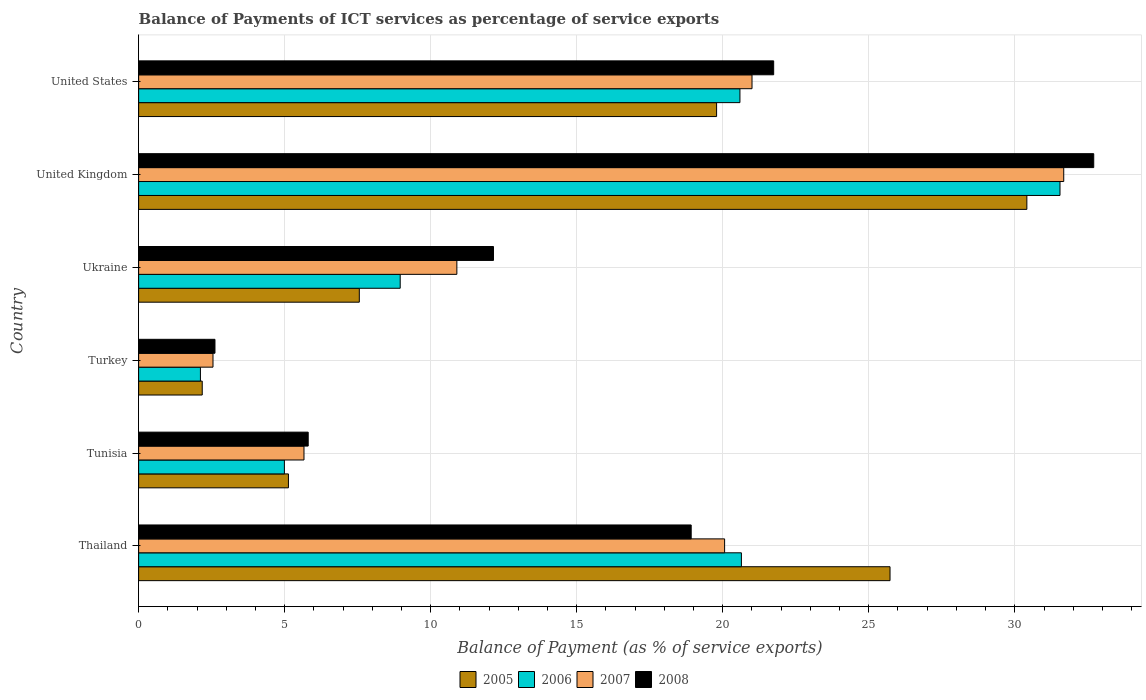How many different coloured bars are there?
Your answer should be compact. 4. How many groups of bars are there?
Your response must be concise. 6. Are the number of bars per tick equal to the number of legend labels?
Your answer should be very brief. Yes. Are the number of bars on each tick of the Y-axis equal?
Give a very brief answer. Yes. How many bars are there on the 1st tick from the top?
Your response must be concise. 4. What is the label of the 6th group of bars from the top?
Provide a short and direct response. Thailand. What is the balance of payments of ICT services in 2005 in Tunisia?
Provide a short and direct response. 5.13. Across all countries, what is the maximum balance of payments of ICT services in 2007?
Provide a succinct answer. 31.68. Across all countries, what is the minimum balance of payments of ICT services in 2008?
Give a very brief answer. 2.61. What is the total balance of payments of ICT services in 2007 in the graph?
Give a very brief answer. 91.85. What is the difference between the balance of payments of ICT services in 2005 in Tunisia and that in United Kingdom?
Your answer should be very brief. -25.28. What is the difference between the balance of payments of ICT services in 2006 in Ukraine and the balance of payments of ICT services in 2008 in United Kingdom?
Offer a terse response. -23.75. What is the average balance of payments of ICT services in 2007 per country?
Offer a very short reply. 15.31. What is the difference between the balance of payments of ICT services in 2007 and balance of payments of ICT services in 2005 in Thailand?
Your response must be concise. -5.66. What is the ratio of the balance of payments of ICT services in 2006 in Tunisia to that in United Kingdom?
Your answer should be very brief. 0.16. Is the balance of payments of ICT services in 2006 in Thailand less than that in Ukraine?
Make the answer very short. No. What is the difference between the highest and the second highest balance of payments of ICT services in 2005?
Your answer should be compact. 4.68. What is the difference between the highest and the lowest balance of payments of ICT services in 2007?
Your answer should be very brief. 29.13. In how many countries, is the balance of payments of ICT services in 2008 greater than the average balance of payments of ICT services in 2008 taken over all countries?
Your answer should be very brief. 3. Is the sum of the balance of payments of ICT services in 2008 in Thailand and Tunisia greater than the maximum balance of payments of ICT services in 2005 across all countries?
Keep it short and to the point. No. Are all the bars in the graph horizontal?
Offer a terse response. Yes. Does the graph contain any zero values?
Provide a succinct answer. No. Does the graph contain grids?
Provide a short and direct response. Yes. Where does the legend appear in the graph?
Keep it short and to the point. Bottom center. How are the legend labels stacked?
Offer a terse response. Horizontal. What is the title of the graph?
Provide a succinct answer. Balance of Payments of ICT services as percentage of service exports. What is the label or title of the X-axis?
Give a very brief answer. Balance of Payment (as % of service exports). What is the label or title of the Y-axis?
Offer a very short reply. Country. What is the Balance of Payment (as % of service exports) of 2005 in Thailand?
Give a very brief answer. 25.73. What is the Balance of Payment (as % of service exports) of 2006 in Thailand?
Provide a short and direct response. 20.64. What is the Balance of Payment (as % of service exports) in 2007 in Thailand?
Your answer should be very brief. 20.06. What is the Balance of Payment (as % of service exports) in 2008 in Thailand?
Give a very brief answer. 18.92. What is the Balance of Payment (as % of service exports) of 2005 in Tunisia?
Ensure brevity in your answer.  5.13. What is the Balance of Payment (as % of service exports) in 2006 in Tunisia?
Your answer should be very brief. 4.99. What is the Balance of Payment (as % of service exports) in 2007 in Tunisia?
Your answer should be compact. 5.66. What is the Balance of Payment (as % of service exports) in 2008 in Tunisia?
Your answer should be compact. 5.81. What is the Balance of Payment (as % of service exports) of 2005 in Turkey?
Your answer should be very brief. 2.18. What is the Balance of Payment (as % of service exports) of 2006 in Turkey?
Your answer should be very brief. 2.12. What is the Balance of Payment (as % of service exports) in 2007 in Turkey?
Your answer should be very brief. 2.55. What is the Balance of Payment (as % of service exports) of 2008 in Turkey?
Give a very brief answer. 2.61. What is the Balance of Payment (as % of service exports) in 2005 in Ukraine?
Provide a succinct answer. 7.56. What is the Balance of Payment (as % of service exports) in 2006 in Ukraine?
Keep it short and to the point. 8.96. What is the Balance of Payment (as % of service exports) in 2007 in Ukraine?
Provide a succinct answer. 10.9. What is the Balance of Payment (as % of service exports) of 2008 in Ukraine?
Offer a very short reply. 12.15. What is the Balance of Payment (as % of service exports) in 2005 in United Kingdom?
Your answer should be compact. 30.41. What is the Balance of Payment (as % of service exports) of 2006 in United Kingdom?
Your answer should be very brief. 31.55. What is the Balance of Payment (as % of service exports) in 2007 in United Kingdom?
Provide a succinct answer. 31.68. What is the Balance of Payment (as % of service exports) of 2008 in United Kingdom?
Offer a very short reply. 32.7. What is the Balance of Payment (as % of service exports) of 2005 in United States?
Make the answer very short. 19.79. What is the Balance of Payment (as % of service exports) in 2006 in United States?
Provide a short and direct response. 20.59. What is the Balance of Payment (as % of service exports) in 2007 in United States?
Offer a terse response. 21. What is the Balance of Payment (as % of service exports) in 2008 in United States?
Your answer should be compact. 21.74. Across all countries, what is the maximum Balance of Payment (as % of service exports) in 2005?
Make the answer very short. 30.41. Across all countries, what is the maximum Balance of Payment (as % of service exports) of 2006?
Provide a succinct answer. 31.55. Across all countries, what is the maximum Balance of Payment (as % of service exports) in 2007?
Ensure brevity in your answer.  31.68. Across all countries, what is the maximum Balance of Payment (as % of service exports) in 2008?
Give a very brief answer. 32.7. Across all countries, what is the minimum Balance of Payment (as % of service exports) in 2005?
Provide a short and direct response. 2.18. Across all countries, what is the minimum Balance of Payment (as % of service exports) of 2006?
Your response must be concise. 2.12. Across all countries, what is the minimum Balance of Payment (as % of service exports) in 2007?
Give a very brief answer. 2.55. Across all countries, what is the minimum Balance of Payment (as % of service exports) in 2008?
Offer a terse response. 2.61. What is the total Balance of Payment (as % of service exports) of 2005 in the graph?
Ensure brevity in your answer.  90.79. What is the total Balance of Payment (as % of service exports) in 2006 in the graph?
Offer a very short reply. 88.84. What is the total Balance of Payment (as % of service exports) of 2007 in the graph?
Give a very brief answer. 91.85. What is the total Balance of Payment (as % of service exports) of 2008 in the graph?
Provide a succinct answer. 93.94. What is the difference between the Balance of Payment (as % of service exports) of 2005 in Thailand and that in Tunisia?
Make the answer very short. 20.6. What is the difference between the Balance of Payment (as % of service exports) in 2006 in Thailand and that in Tunisia?
Offer a very short reply. 15.65. What is the difference between the Balance of Payment (as % of service exports) in 2007 in Thailand and that in Tunisia?
Give a very brief answer. 14.4. What is the difference between the Balance of Payment (as % of service exports) in 2008 in Thailand and that in Tunisia?
Ensure brevity in your answer.  13.11. What is the difference between the Balance of Payment (as % of service exports) in 2005 in Thailand and that in Turkey?
Keep it short and to the point. 23.55. What is the difference between the Balance of Payment (as % of service exports) of 2006 in Thailand and that in Turkey?
Your response must be concise. 18.52. What is the difference between the Balance of Payment (as % of service exports) of 2007 in Thailand and that in Turkey?
Give a very brief answer. 17.52. What is the difference between the Balance of Payment (as % of service exports) of 2008 in Thailand and that in Turkey?
Your answer should be compact. 16.31. What is the difference between the Balance of Payment (as % of service exports) of 2005 in Thailand and that in Ukraine?
Offer a terse response. 18.17. What is the difference between the Balance of Payment (as % of service exports) in 2006 in Thailand and that in Ukraine?
Your response must be concise. 11.68. What is the difference between the Balance of Payment (as % of service exports) of 2007 in Thailand and that in Ukraine?
Provide a short and direct response. 9.17. What is the difference between the Balance of Payment (as % of service exports) in 2008 in Thailand and that in Ukraine?
Ensure brevity in your answer.  6.77. What is the difference between the Balance of Payment (as % of service exports) of 2005 in Thailand and that in United Kingdom?
Ensure brevity in your answer.  -4.68. What is the difference between the Balance of Payment (as % of service exports) of 2006 in Thailand and that in United Kingdom?
Provide a succinct answer. -10.91. What is the difference between the Balance of Payment (as % of service exports) in 2007 in Thailand and that in United Kingdom?
Provide a succinct answer. -11.61. What is the difference between the Balance of Payment (as % of service exports) in 2008 in Thailand and that in United Kingdom?
Offer a very short reply. -13.78. What is the difference between the Balance of Payment (as % of service exports) of 2005 in Thailand and that in United States?
Give a very brief answer. 5.94. What is the difference between the Balance of Payment (as % of service exports) in 2006 in Thailand and that in United States?
Your answer should be compact. 0.05. What is the difference between the Balance of Payment (as % of service exports) in 2007 in Thailand and that in United States?
Your answer should be compact. -0.94. What is the difference between the Balance of Payment (as % of service exports) in 2008 in Thailand and that in United States?
Make the answer very short. -2.82. What is the difference between the Balance of Payment (as % of service exports) in 2005 in Tunisia and that in Turkey?
Make the answer very short. 2.95. What is the difference between the Balance of Payment (as % of service exports) in 2006 in Tunisia and that in Turkey?
Your response must be concise. 2.88. What is the difference between the Balance of Payment (as % of service exports) in 2007 in Tunisia and that in Turkey?
Make the answer very short. 3.12. What is the difference between the Balance of Payment (as % of service exports) in 2008 in Tunisia and that in Turkey?
Make the answer very short. 3.19. What is the difference between the Balance of Payment (as % of service exports) in 2005 in Tunisia and that in Ukraine?
Offer a very short reply. -2.43. What is the difference between the Balance of Payment (as % of service exports) of 2006 in Tunisia and that in Ukraine?
Provide a short and direct response. -3.97. What is the difference between the Balance of Payment (as % of service exports) of 2007 in Tunisia and that in Ukraine?
Ensure brevity in your answer.  -5.23. What is the difference between the Balance of Payment (as % of service exports) in 2008 in Tunisia and that in Ukraine?
Your response must be concise. -6.34. What is the difference between the Balance of Payment (as % of service exports) in 2005 in Tunisia and that in United Kingdom?
Your answer should be very brief. -25.28. What is the difference between the Balance of Payment (as % of service exports) of 2006 in Tunisia and that in United Kingdom?
Keep it short and to the point. -26.56. What is the difference between the Balance of Payment (as % of service exports) in 2007 in Tunisia and that in United Kingdom?
Give a very brief answer. -26.01. What is the difference between the Balance of Payment (as % of service exports) in 2008 in Tunisia and that in United Kingdom?
Provide a short and direct response. -26.9. What is the difference between the Balance of Payment (as % of service exports) in 2005 in Tunisia and that in United States?
Give a very brief answer. -14.66. What is the difference between the Balance of Payment (as % of service exports) of 2006 in Tunisia and that in United States?
Your response must be concise. -15.6. What is the difference between the Balance of Payment (as % of service exports) of 2007 in Tunisia and that in United States?
Provide a succinct answer. -15.34. What is the difference between the Balance of Payment (as % of service exports) of 2008 in Tunisia and that in United States?
Your answer should be compact. -15.94. What is the difference between the Balance of Payment (as % of service exports) of 2005 in Turkey and that in Ukraine?
Keep it short and to the point. -5.38. What is the difference between the Balance of Payment (as % of service exports) in 2006 in Turkey and that in Ukraine?
Offer a very short reply. -6.84. What is the difference between the Balance of Payment (as % of service exports) of 2007 in Turkey and that in Ukraine?
Give a very brief answer. -8.35. What is the difference between the Balance of Payment (as % of service exports) of 2008 in Turkey and that in Ukraine?
Provide a succinct answer. -9.54. What is the difference between the Balance of Payment (as % of service exports) in 2005 in Turkey and that in United Kingdom?
Keep it short and to the point. -28.23. What is the difference between the Balance of Payment (as % of service exports) of 2006 in Turkey and that in United Kingdom?
Provide a succinct answer. -29.43. What is the difference between the Balance of Payment (as % of service exports) in 2007 in Turkey and that in United Kingdom?
Your response must be concise. -29.13. What is the difference between the Balance of Payment (as % of service exports) of 2008 in Turkey and that in United Kingdom?
Ensure brevity in your answer.  -30.09. What is the difference between the Balance of Payment (as % of service exports) of 2005 in Turkey and that in United States?
Your answer should be very brief. -17.61. What is the difference between the Balance of Payment (as % of service exports) in 2006 in Turkey and that in United States?
Offer a very short reply. -18.47. What is the difference between the Balance of Payment (as % of service exports) of 2007 in Turkey and that in United States?
Provide a short and direct response. -18.46. What is the difference between the Balance of Payment (as % of service exports) in 2008 in Turkey and that in United States?
Offer a terse response. -19.13. What is the difference between the Balance of Payment (as % of service exports) in 2005 in Ukraine and that in United Kingdom?
Ensure brevity in your answer.  -22.86. What is the difference between the Balance of Payment (as % of service exports) in 2006 in Ukraine and that in United Kingdom?
Your answer should be compact. -22.59. What is the difference between the Balance of Payment (as % of service exports) of 2007 in Ukraine and that in United Kingdom?
Provide a short and direct response. -20.78. What is the difference between the Balance of Payment (as % of service exports) of 2008 in Ukraine and that in United Kingdom?
Give a very brief answer. -20.55. What is the difference between the Balance of Payment (as % of service exports) of 2005 in Ukraine and that in United States?
Ensure brevity in your answer.  -12.23. What is the difference between the Balance of Payment (as % of service exports) in 2006 in Ukraine and that in United States?
Keep it short and to the point. -11.63. What is the difference between the Balance of Payment (as % of service exports) of 2007 in Ukraine and that in United States?
Your answer should be compact. -10.11. What is the difference between the Balance of Payment (as % of service exports) in 2008 in Ukraine and that in United States?
Provide a succinct answer. -9.59. What is the difference between the Balance of Payment (as % of service exports) in 2005 in United Kingdom and that in United States?
Keep it short and to the point. 10.62. What is the difference between the Balance of Payment (as % of service exports) in 2006 in United Kingdom and that in United States?
Your answer should be very brief. 10.96. What is the difference between the Balance of Payment (as % of service exports) of 2007 in United Kingdom and that in United States?
Keep it short and to the point. 10.67. What is the difference between the Balance of Payment (as % of service exports) in 2008 in United Kingdom and that in United States?
Provide a short and direct response. 10.96. What is the difference between the Balance of Payment (as % of service exports) in 2005 in Thailand and the Balance of Payment (as % of service exports) in 2006 in Tunisia?
Keep it short and to the point. 20.74. What is the difference between the Balance of Payment (as % of service exports) of 2005 in Thailand and the Balance of Payment (as % of service exports) of 2007 in Tunisia?
Give a very brief answer. 20.07. What is the difference between the Balance of Payment (as % of service exports) in 2005 in Thailand and the Balance of Payment (as % of service exports) in 2008 in Tunisia?
Keep it short and to the point. 19.92. What is the difference between the Balance of Payment (as % of service exports) in 2006 in Thailand and the Balance of Payment (as % of service exports) in 2007 in Tunisia?
Keep it short and to the point. 14.98. What is the difference between the Balance of Payment (as % of service exports) in 2006 in Thailand and the Balance of Payment (as % of service exports) in 2008 in Tunisia?
Your response must be concise. 14.83. What is the difference between the Balance of Payment (as % of service exports) of 2007 in Thailand and the Balance of Payment (as % of service exports) of 2008 in Tunisia?
Offer a very short reply. 14.26. What is the difference between the Balance of Payment (as % of service exports) of 2005 in Thailand and the Balance of Payment (as % of service exports) of 2006 in Turkey?
Give a very brief answer. 23.61. What is the difference between the Balance of Payment (as % of service exports) in 2005 in Thailand and the Balance of Payment (as % of service exports) in 2007 in Turkey?
Your answer should be very brief. 23.18. What is the difference between the Balance of Payment (as % of service exports) in 2005 in Thailand and the Balance of Payment (as % of service exports) in 2008 in Turkey?
Your response must be concise. 23.11. What is the difference between the Balance of Payment (as % of service exports) in 2006 in Thailand and the Balance of Payment (as % of service exports) in 2007 in Turkey?
Your response must be concise. 18.09. What is the difference between the Balance of Payment (as % of service exports) in 2006 in Thailand and the Balance of Payment (as % of service exports) in 2008 in Turkey?
Ensure brevity in your answer.  18.03. What is the difference between the Balance of Payment (as % of service exports) of 2007 in Thailand and the Balance of Payment (as % of service exports) of 2008 in Turkey?
Provide a short and direct response. 17.45. What is the difference between the Balance of Payment (as % of service exports) in 2005 in Thailand and the Balance of Payment (as % of service exports) in 2006 in Ukraine?
Your answer should be compact. 16.77. What is the difference between the Balance of Payment (as % of service exports) in 2005 in Thailand and the Balance of Payment (as % of service exports) in 2007 in Ukraine?
Keep it short and to the point. 14.83. What is the difference between the Balance of Payment (as % of service exports) in 2005 in Thailand and the Balance of Payment (as % of service exports) in 2008 in Ukraine?
Give a very brief answer. 13.58. What is the difference between the Balance of Payment (as % of service exports) of 2006 in Thailand and the Balance of Payment (as % of service exports) of 2007 in Ukraine?
Provide a short and direct response. 9.74. What is the difference between the Balance of Payment (as % of service exports) in 2006 in Thailand and the Balance of Payment (as % of service exports) in 2008 in Ukraine?
Offer a very short reply. 8.49. What is the difference between the Balance of Payment (as % of service exports) in 2007 in Thailand and the Balance of Payment (as % of service exports) in 2008 in Ukraine?
Provide a short and direct response. 7.91. What is the difference between the Balance of Payment (as % of service exports) of 2005 in Thailand and the Balance of Payment (as % of service exports) of 2006 in United Kingdom?
Make the answer very short. -5.82. What is the difference between the Balance of Payment (as % of service exports) in 2005 in Thailand and the Balance of Payment (as % of service exports) in 2007 in United Kingdom?
Your response must be concise. -5.95. What is the difference between the Balance of Payment (as % of service exports) of 2005 in Thailand and the Balance of Payment (as % of service exports) of 2008 in United Kingdom?
Give a very brief answer. -6.97. What is the difference between the Balance of Payment (as % of service exports) of 2006 in Thailand and the Balance of Payment (as % of service exports) of 2007 in United Kingdom?
Offer a terse response. -11.04. What is the difference between the Balance of Payment (as % of service exports) in 2006 in Thailand and the Balance of Payment (as % of service exports) in 2008 in United Kingdom?
Ensure brevity in your answer.  -12.06. What is the difference between the Balance of Payment (as % of service exports) of 2007 in Thailand and the Balance of Payment (as % of service exports) of 2008 in United Kingdom?
Ensure brevity in your answer.  -12.64. What is the difference between the Balance of Payment (as % of service exports) of 2005 in Thailand and the Balance of Payment (as % of service exports) of 2006 in United States?
Make the answer very short. 5.14. What is the difference between the Balance of Payment (as % of service exports) in 2005 in Thailand and the Balance of Payment (as % of service exports) in 2007 in United States?
Offer a very short reply. 4.73. What is the difference between the Balance of Payment (as % of service exports) of 2005 in Thailand and the Balance of Payment (as % of service exports) of 2008 in United States?
Ensure brevity in your answer.  3.98. What is the difference between the Balance of Payment (as % of service exports) of 2006 in Thailand and the Balance of Payment (as % of service exports) of 2007 in United States?
Your answer should be compact. -0.36. What is the difference between the Balance of Payment (as % of service exports) of 2006 in Thailand and the Balance of Payment (as % of service exports) of 2008 in United States?
Give a very brief answer. -1.1. What is the difference between the Balance of Payment (as % of service exports) in 2007 in Thailand and the Balance of Payment (as % of service exports) in 2008 in United States?
Ensure brevity in your answer.  -1.68. What is the difference between the Balance of Payment (as % of service exports) of 2005 in Tunisia and the Balance of Payment (as % of service exports) of 2006 in Turkey?
Make the answer very short. 3.01. What is the difference between the Balance of Payment (as % of service exports) in 2005 in Tunisia and the Balance of Payment (as % of service exports) in 2007 in Turkey?
Provide a succinct answer. 2.58. What is the difference between the Balance of Payment (as % of service exports) in 2005 in Tunisia and the Balance of Payment (as % of service exports) in 2008 in Turkey?
Provide a short and direct response. 2.52. What is the difference between the Balance of Payment (as % of service exports) of 2006 in Tunisia and the Balance of Payment (as % of service exports) of 2007 in Turkey?
Offer a very short reply. 2.44. What is the difference between the Balance of Payment (as % of service exports) in 2006 in Tunisia and the Balance of Payment (as % of service exports) in 2008 in Turkey?
Offer a very short reply. 2.38. What is the difference between the Balance of Payment (as % of service exports) in 2007 in Tunisia and the Balance of Payment (as % of service exports) in 2008 in Turkey?
Keep it short and to the point. 3.05. What is the difference between the Balance of Payment (as % of service exports) in 2005 in Tunisia and the Balance of Payment (as % of service exports) in 2006 in Ukraine?
Your response must be concise. -3.83. What is the difference between the Balance of Payment (as % of service exports) in 2005 in Tunisia and the Balance of Payment (as % of service exports) in 2007 in Ukraine?
Your answer should be very brief. -5.77. What is the difference between the Balance of Payment (as % of service exports) in 2005 in Tunisia and the Balance of Payment (as % of service exports) in 2008 in Ukraine?
Give a very brief answer. -7.02. What is the difference between the Balance of Payment (as % of service exports) in 2006 in Tunisia and the Balance of Payment (as % of service exports) in 2007 in Ukraine?
Give a very brief answer. -5.91. What is the difference between the Balance of Payment (as % of service exports) in 2006 in Tunisia and the Balance of Payment (as % of service exports) in 2008 in Ukraine?
Your answer should be very brief. -7.16. What is the difference between the Balance of Payment (as % of service exports) of 2007 in Tunisia and the Balance of Payment (as % of service exports) of 2008 in Ukraine?
Your response must be concise. -6.49. What is the difference between the Balance of Payment (as % of service exports) of 2005 in Tunisia and the Balance of Payment (as % of service exports) of 2006 in United Kingdom?
Give a very brief answer. -26.42. What is the difference between the Balance of Payment (as % of service exports) of 2005 in Tunisia and the Balance of Payment (as % of service exports) of 2007 in United Kingdom?
Your answer should be compact. -26.55. What is the difference between the Balance of Payment (as % of service exports) in 2005 in Tunisia and the Balance of Payment (as % of service exports) in 2008 in United Kingdom?
Provide a short and direct response. -27.57. What is the difference between the Balance of Payment (as % of service exports) in 2006 in Tunisia and the Balance of Payment (as % of service exports) in 2007 in United Kingdom?
Ensure brevity in your answer.  -26.68. What is the difference between the Balance of Payment (as % of service exports) in 2006 in Tunisia and the Balance of Payment (as % of service exports) in 2008 in United Kingdom?
Ensure brevity in your answer.  -27.71. What is the difference between the Balance of Payment (as % of service exports) of 2007 in Tunisia and the Balance of Payment (as % of service exports) of 2008 in United Kingdom?
Your answer should be compact. -27.04. What is the difference between the Balance of Payment (as % of service exports) of 2005 in Tunisia and the Balance of Payment (as % of service exports) of 2006 in United States?
Your response must be concise. -15.46. What is the difference between the Balance of Payment (as % of service exports) in 2005 in Tunisia and the Balance of Payment (as % of service exports) in 2007 in United States?
Your answer should be very brief. -15.87. What is the difference between the Balance of Payment (as % of service exports) in 2005 in Tunisia and the Balance of Payment (as % of service exports) in 2008 in United States?
Provide a short and direct response. -16.61. What is the difference between the Balance of Payment (as % of service exports) in 2006 in Tunisia and the Balance of Payment (as % of service exports) in 2007 in United States?
Your answer should be compact. -16.01. What is the difference between the Balance of Payment (as % of service exports) in 2006 in Tunisia and the Balance of Payment (as % of service exports) in 2008 in United States?
Ensure brevity in your answer.  -16.75. What is the difference between the Balance of Payment (as % of service exports) of 2007 in Tunisia and the Balance of Payment (as % of service exports) of 2008 in United States?
Provide a succinct answer. -16.08. What is the difference between the Balance of Payment (as % of service exports) in 2005 in Turkey and the Balance of Payment (as % of service exports) in 2006 in Ukraine?
Your answer should be compact. -6.78. What is the difference between the Balance of Payment (as % of service exports) of 2005 in Turkey and the Balance of Payment (as % of service exports) of 2007 in Ukraine?
Offer a terse response. -8.72. What is the difference between the Balance of Payment (as % of service exports) in 2005 in Turkey and the Balance of Payment (as % of service exports) in 2008 in Ukraine?
Offer a very short reply. -9.97. What is the difference between the Balance of Payment (as % of service exports) of 2006 in Turkey and the Balance of Payment (as % of service exports) of 2007 in Ukraine?
Your answer should be very brief. -8.78. What is the difference between the Balance of Payment (as % of service exports) in 2006 in Turkey and the Balance of Payment (as % of service exports) in 2008 in Ukraine?
Ensure brevity in your answer.  -10.03. What is the difference between the Balance of Payment (as % of service exports) in 2007 in Turkey and the Balance of Payment (as % of service exports) in 2008 in Ukraine?
Give a very brief answer. -9.6. What is the difference between the Balance of Payment (as % of service exports) of 2005 in Turkey and the Balance of Payment (as % of service exports) of 2006 in United Kingdom?
Provide a short and direct response. -29.37. What is the difference between the Balance of Payment (as % of service exports) in 2005 in Turkey and the Balance of Payment (as % of service exports) in 2007 in United Kingdom?
Keep it short and to the point. -29.5. What is the difference between the Balance of Payment (as % of service exports) in 2005 in Turkey and the Balance of Payment (as % of service exports) in 2008 in United Kingdom?
Offer a terse response. -30.52. What is the difference between the Balance of Payment (as % of service exports) in 2006 in Turkey and the Balance of Payment (as % of service exports) in 2007 in United Kingdom?
Ensure brevity in your answer.  -29.56. What is the difference between the Balance of Payment (as % of service exports) of 2006 in Turkey and the Balance of Payment (as % of service exports) of 2008 in United Kingdom?
Your answer should be very brief. -30.59. What is the difference between the Balance of Payment (as % of service exports) in 2007 in Turkey and the Balance of Payment (as % of service exports) in 2008 in United Kingdom?
Provide a short and direct response. -30.16. What is the difference between the Balance of Payment (as % of service exports) of 2005 in Turkey and the Balance of Payment (as % of service exports) of 2006 in United States?
Provide a succinct answer. -18.41. What is the difference between the Balance of Payment (as % of service exports) of 2005 in Turkey and the Balance of Payment (as % of service exports) of 2007 in United States?
Keep it short and to the point. -18.82. What is the difference between the Balance of Payment (as % of service exports) of 2005 in Turkey and the Balance of Payment (as % of service exports) of 2008 in United States?
Your answer should be very brief. -19.57. What is the difference between the Balance of Payment (as % of service exports) of 2006 in Turkey and the Balance of Payment (as % of service exports) of 2007 in United States?
Keep it short and to the point. -18.89. What is the difference between the Balance of Payment (as % of service exports) in 2006 in Turkey and the Balance of Payment (as % of service exports) in 2008 in United States?
Your answer should be compact. -19.63. What is the difference between the Balance of Payment (as % of service exports) of 2007 in Turkey and the Balance of Payment (as % of service exports) of 2008 in United States?
Your response must be concise. -19.2. What is the difference between the Balance of Payment (as % of service exports) in 2005 in Ukraine and the Balance of Payment (as % of service exports) in 2006 in United Kingdom?
Keep it short and to the point. -23.99. What is the difference between the Balance of Payment (as % of service exports) in 2005 in Ukraine and the Balance of Payment (as % of service exports) in 2007 in United Kingdom?
Offer a very short reply. -24.12. What is the difference between the Balance of Payment (as % of service exports) in 2005 in Ukraine and the Balance of Payment (as % of service exports) in 2008 in United Kingdom?
Your response must be concise. -25.15. What is the difference between the Balance of Payment (as % of service exports) of 2006 in Ukraine and the Balance of Payment (as % of service exports) of 2007 in United Kingdom?
Ensure brevity in your answer.  -22.72. What is the difference between the Balance of Payment (as % of service exports) in 2006 in Ukraine and the Balance of Payment (as % of service exports) in 2008 in United Kingdom?
Make the answer very short. -23.75. What is the difference between the Balance of Payment (as % of service exports) in 2007 in Ukraine and the Balance of Payment (as % of service exports) in 2008 in United Kingdom?
Offer a terse response. -21.81. What is the difference between the Balance of Payment (as % of service exports) of 2005 in Ukraine and the Balance of Payment (as % of service exports) of 2006 in United States?
Your answer should be compact. -13.03. What is the difference between the Balance of Payment (as % of service exports) in 2005 in Ukraine and the Balance of Payment (as % of service exports) in 2007 in United States?
Ensure brevity in your answer.  -13.45. What is the difference between the Balance of Payment (as % of service exports) of 2005 in Ukraine and the Balance of Payment (as % of service exports) of 2008 in United States?
Your answer should be very brief. -14.19. What is the difference between the Balance of Payment (as % of service exports) of 2006 in Ukraine and the Balance of Payment (as % of service exports) of 2007 in United States?
Ensure brevity in your answer.  -12.05. What is the difference between the Balance of Payment (as % of service exports) of 2006 in Ukraine and the Balance of Payment (as % of service exports) of 2008 in United States?
Keep it short and to the point. -12.79. What is the difference between the Balance of Payment (as % of service exports) in 2007 in Ukraine and the Balance of Payment (as % of service exports) in 2008 in United States?
Offer a terse response. -10.85. What is the difference between the Balance of Payment (as % of service exports) in 2005 in United Kingdom and the Balance of Payment (as % of service exports) in 2006 in United States?
Your answer should be very brief. 9.82. What is the difference between the Balance of Payment (as % of service exports) in 2005 in United Kingdom and the Balance of Payment (as % of service exports) in 2007 in United States?
Provide a succinct answer. 9.41. What is the difference between the Balance of Payment (as % of service exports) of 2005 in United Kingdom and the Balance of Payment (as % of service exports) of 2008 in United States?
Provide a succinct answer. 8.67. What is the difference between the Balance of Payment (as % of service exports) in 2006 in United Kingdom and the Balance of Payment (as % of service exports) in 2007 in United States?
Your answer should be very brief. 10.55. What is the difference between the Balance of Payment (as % of service exports) of 2006 in United Kingdom and the Balance of Payment (as % of service exports) of 2008 in United States?
Your response must be concise. 9.8. What is the difference between the Balance of Payment (as % of service exports) in 2007 in United Kingdom and the Balance of Payment (as % of service exports) in 2008 in United States?
Offer a terse response. 9.93. What is the average Balance of Payment (as % of service exports) in 2005 per country?
Provide a short and direct response. 15.13. What is the average Balance of Payment (as % of service exports) of 2006 per country?
Provide a succinct answer. 14.81. What is the average Balance of Payment (as % of service exports) in 2007 per country?
Provide a short and direct response. 15.31. What is the average Balance of Payment (as % of service exports) of 2008 per country?
Make the answer very short. 15.66. What is the difference between the Balance of Payment (as % of service exports) in 2005 and Balance of Payment (as % of service exports) in 2006 in Thailand?
Give a very brief answer. 5.09. What is the difference between the Balance of Payment (as % of service exports) in 2005 and Balance of Payment (as % of service exports) in 2007 in Thailand?
Give a very brief answer. 5.66. What is the difference between the Balance of Payment (as % of service exports) in 2005 and Balance of Payment (as % of service exports) in 2008 in Thailand?
Provide a short and direct response. 6.81. What is the difference between the Balance of Payment (as % of service exports) of 2006 and Balance of Payment (as % of service exports) of 2007 in Thailand?
Offer a terse response. 0.58. What is the difference between the Balance of Payment (as % of service exports) in 2006 and Balance of Payment (as % of service exports) in 2008 in Thailand?
Offer a terse response. 1.72. What is the difference between the Balance of Payment (as % of service exports) of 2007 and Balance of Payment (as % of service exports) of 2008 in Thailand?
Your answer should be compact. 1.14. What is the difference between the Balance of Payment (as % of service exports) of 2005 and Balance of Payment (as % of service exports) of 2006 in Tunisia?
Keep it short and to the point. 0.14. What is the difference between the Balance of Payment (as % of service exports) in 2005 and Balance of Payment (as % of service exports) in 2007 in Tunisia?
Provide a short and direct response. -0.53. What is the difference between the Balance of Payment (as % of service exports) in 2005 and Balance of Payment (as % of service exports) in 2008 in Tunisia?
Keep it short and to the point. -0.68. What is the difference between the Balance of Payment (as % of service exports) in 2006 and Balance of Payment (as % of service exports) in 2007 in Tunisia?
Provide a short and direct response. -0.67. What is the difference between the Balance of Payment (as % of service exports) of 2006 and Balance of Payment (as % of service exports) of 2008 in Tunisia?
Your answer should be compact. -0.82. What is the difference between the Balance of Payment (as % of service exports) of 2007 and Balance of Payment (as % of service exports) of 2008 in Tunisia?
Give a very brief answer. -0.14. What is the difference between the Balance of Payment (as % of service exports) of 2005 and Balance of Payment (as % of service exports) of 2006 in Turkey?
Your response must be concise. 0.06. What is the difference between the Balance of Payment (as % of service exports) of 2005 and Balance of Payment (as % of service exports) of 2007 in Turkey?
Offer a very short reply. -0.37. What is the difference between the Balance of Payment (as % of service exports) of 2005 and Balance of Payment (as % of service exports) of 2008 in Turkey?
Ensure brevity in your answer.  -0.44. What is the difference between the Balance of Payment (as % of service exports) in 2006 and Balance of Payment (as % of service exports) in 2007 in Turkey?
Keep it short and to the point. -0.43. What is the difference between the Balance of Payment (as % of service exports) in 2006 and Balance of Payment (as % of service exports) in 2008 in Turkey?
Provide a short and direct response. -0.5. What is the difference between the Balance of Payment (as % of service exports) of 2007 and Balance of Payment (as % of service exports) of 2008 in Turkey?
Offer a terse response. -0.07. What is the difference between the Balance of Payment (as % of service exports) in 2005 and Balance of Payment (as % of service exports) in 2006 in Ukraine?
Offer a very short reply. -1.4. What is the difference between the Balance of Payment (as % of service exports) of 2005 and Balance of Payment (as % of service exports) of 2007 in Ukraine?
Offer a terse response. -3.34. What is the difference between the Balance of Payment (as % of service exports) of 2005 and Balance of Payment (as % of service exports) of 2008 in Ukraine?
Keep it short and to the point. -4.59. What is the difference between the Balance of Payment (as % of service exports) of 2006 and Balance of Payment (as % of service exports) of 2007 in Ukraine?
Give a very brief answer. -1.94. What is the difference between the Balance of Payment (as % of service exports) in 2006 and Balance of Payment (as % of service exports) in 2008 in Ukraine?
Make the answer very short. -3.19. What is the difference between the Balance of Payment (as % of service exports) of 2007 and Balance of Payment (as % of service exports) of 2008 in Ukraine?
Your answer should be compact. -1.25. What is the difference between the Balance of Payment (as % of service exports) in 2005 and Balance of Payment (as % of service exports) in 2006 in United Kingdom?
Keep it short and to the point. -1.14. What is the difference between the Balance of Payment (as % of service exports) of 2005 and Balance of Payment (as % of service exports) of 2007 in United Kingdom?
Your answer should be very brief. -1.26. What is the difference between the Balance of Payment (as % of service exports) in 2005 and Balance of Payment (as % of service exports) in 2008 in United Kingdom?
Your answer should be compact. -2.29. What is the difference between the Balance of Payment (as % of service exports) of 2006 and Balance of Payment (as % of service exports) of 2007 in United Kingdom?
Your response must be concise. -0.13. What is the difference between the Balance of Payment (as % of service exports) of 2006 and Balance of Payment (as % of service exports) of 2008 in United Kingdom?
Make the answer very short. -1.16. What is the difference between the Balance of Payment (as % of service exports) of 2007 and Balance of Payment (as % of service exports) of 2008 in United Kingdom?
Provide a succinct answer. -1.03. What is the difference between the Balance of Payment (as % of service exports) of 2005 and Balance of Payment (as % of service exports) of 2006 in United States?
Offer a very short reply. -0.8. What is the difference between the Balance of Payment (as % of service exports) of 2005 and Balance of Payment (as % of service exports) of 2007 in United States?
Ensure brevity in your answer.  -1.21. What is the difference between the Balance of Payment (as % of service exports) in 2005 and Balance of Payment (as % of service exports) in 2008 in United States?
Offer a terse response. -1.95. What is the difference between the Balance of Payment (as % of service exports) in 2006 and Balance of Payment (as % of service exports) in 2007 in United States?
Provide a short and direct response. -0.41. What is the difference between the Balance of Payment (as % of service exports) of 2006 and Balance of Payment (as % of service exports) of 2008 in United States?
Make the answer very short. -1.15. What is the difference between the Balance of Payment (as % of service exports) of 2007 and Balance of Payment (as % of service exports) of 2008 in United States?
Provide a short and direct response. -0.74. What is the ratio of the Balance of Payment (as % of service exports) in 2005 in Thailand to that in Tunisia?
Your response must be concise. 5.02. What is the ratio of the Balance of Payment (as % of service exports) of 2006 in Thailand to that in Tunisia?
Offer a very short reply. 4.14. What is the ratio of the Balance of Payment (as % of service exports) in 2007 in Thailand to that in Tunisia?
Your response must be concise. 3.54. What is the ratio of the Balance of Payment (as % of service exports) of 2008 in Thailand to that in Tunisia?
Offer a very short reply. 3.26. What is the ratio of the Balance of Payment (as % of service exports) of 2005 in Thailand to that in Turkey?
Your answer should be compact. 11.81. What is the ratio of the Balance of Payment (as % of service exports) of 2006 in Thailand to that in Turkey?
Your answer should be very brief. 9.75. What is the ratio of the Balance of Payment (as % of service exports) of 2007 in Thailand to that in Turkey?
Keep it short and to the point. 7.88. What is the ratio of the Balance of Payment (as % of service exports) of 2008 in Thailand to that in Turkey?
Make the answer very short. 7.24. What is the ratio of the Balance of Payment (as % of service exports) of 2005 in Thailand to that in Ukraine?
Make the answer very short. 3.4. What is the ratio of the Balance of Payment (as % of service exports) of 2006 in Thailand to that in Ukraine?
Offer a very short reply. 2.3. What is the ratio of the Balance of Payment (as % of service exports) of 2007 in Thailand to that in Ukraine?
Provide a short and direct response. 1.84. What is the ratio of the Balance of Payment (as % of service exports) in 2008 in Thailand to that in Ukraine?
Offer a terse response. 1.56. What is the ratio of the Balance of Payment (as % of service exports) of 2005 in Thailand to that in United Kingdom?
Offer a very short reply. 0.85. What is the ratio of the Balance of Payment (as % of service exports) in 2006 in Thailand to that in United Kingdom?
Give a very brief answer. 0.65. What is the ratio of the Balance of Payment (as % of service exports) in 2007 in Thailand to that in United Kingdom?
Offer a terse response. 0.63. What is the ratio of the Balance of Payment (as % of service exports) in 2008 in Thailand to that in United Kingdom?
Give a very brief answer. 0.58. What is the ratio of the Balance of Payment (as % of service exports) of 2005 in Thailand to that in United States?
Offer a very short reply. 1.3. What is the ratio of the Balance of Payment (as % of service exports) of 2006 in Thailand to that in United States?
Make the answer very short. 1. What is the ratio of the Balance of Payment (as % of service exports) in 2007 in Thailand to that in United States?
Your answer should be compact. 0.96. What is the ratio of the Balance of Payment (as % of service exports) of 2008 in Thailand to that in United States?
Your answer should be compact. 0.87. What is the ratio of the Balance of Payment (as % of service exports) of 2005 in Tunisia to that in Turkey?
Your answer should be compact. 2.35. What is the ratio of the Balance of Payment (as % of service exports) of 2006 in Tunisia to that in Turkey?
Your answer should be very brief. 2.36. What is the ratio of the Balance of Payment (as % of service exports) of 2007 in Tunisia to that in Turkey?
Provide a short and direct response. 2.22. What is the ratio of the Balance of Payment (as % of service exports) of 2008 in Tunisia to that in Turkey?
Ensure brevity in your answer.  2.22. What is the ratio of the Balance of Payment (as % of service exports) in 2005 in Tunisia to that in Ukraine?
Provide a succinct answer. 0.68. What is the ratio of the Balance of Payment (as % of service exports) of 2006 in Tunisia to that in Ukraine?
Offer a very short reply. 0.56. What is the ratio of the Balance of Payment (as % of service exports) in 2007 in Tunisia to that in Ukraine?
Offer a terse response. 0.52. What is the ratio of the Balance of Payment (as % of service exports) of 2008 in Tunisia to that in Ukraine?
Your response must be concise. 0.48. What is the ratio of the Balance of Payment (as % of service exports) of 2005 in Tunisia to that in United Kingdom?
Offer a very short reply. 0.17. What is the ratio of the Balance of Payment (as % of service exports) in 2006 in Tunisia to that in United Kingdom?
Make the answer very short. 0.16. What is the ratio of the Balance of Payment (as % of service exports) of 2007 in Tunisia to that in United Kingdom?
Your answer should be compact. 0.18. What is the ratio of the Balance of Payment (as % of service exports) of 2008 in Tunisia to that in United Kingdom?
Make the answer very short. 0.18. What is the ratio of the Balance of Payment (as % of service exports) of 2005 in Tunisia to that in United States?
Your answer should be compact. 0.26. What is the ratio of the Balance of Payment (as % of service exports) in 2006 in Tunisia to that in United States?
Ensure brevity in your answer.  0.24. What is the ratio of the Balance of Payment (as % of service exports) in 2007 in Tunisia to that in United States?
Your response must be concise. 0.27. What is the ratio of the Balance of Payment (as % of service exports) in 2008 in Tunisia to that in United States?
Offer a very short reply. 0.27. What is the ratio of the Balance of Payment (as % of service exports) of 2005 in Turkey to that in Ukraine?
Provide a succinct answer. 0.29. What is the ratio of the Balance of Payment (as % of service exports) in 2006 in Turkey to that in Ukraine?
Ensure brevity in your answer.  0.24. What is the ratio of the Balance of Payment (as % of service exports) of 2007 in Turkey to that in Ukraine?
Your response must be concise. 0.23. What is the ratio of the Balance of Payment (as % of service exports) of 2008 in Turkey to that in Ukraine?
Offer a very short reply. 0.22. What is the ratio of the Balance of Payment (as % of service exports) of 2005 in Turkey to that in United Kingdom?
Your answer should be very brief. 0.07. What is the ratio of the Balance of Payment (as % of service exports) of 2006 in Turkey to that in United Kingdom?
Provide a succinct answer. 0.07. What is the ratio of the Balance of Payment (as % of service exports) of 2007 in Turkey to that in United Kingdom?
Give a very brief answer. 0.08. What is the ratio of the Balance of Payment (as % of service exports) in 2008 in Turkey to that in United Kingdom?
Your response must be concise. 0.08. What is the ratio of the Balance of Payment (as % of service exports) in 2005 in Turkey to that in United States?
Your response must be concise. 0.11. What is the ratio of the Balance of Payment (as % of service exports) of 2006 in Turkey to that in United States?
Offer a terse response. 0.1. What is the ratio of the Balance of Payment (as % of service exports) in 2007 in Turkey to that in United States?
Offer a very short reply. 0.12. What is the ratio of the Balance of Payment (as % of service exports) in 2008 in Turkey to that in United States?
Your response must be concise. 0.12. What is the ratio of the Balance of Payment (as % of service exports) in 2005 in Ukraine to that in United Kingdom?
Your response must be concise. 0.25. What is the ratio of the Balance of Payment (as % of service exports) of 2006 in Ukraine to that in United Kingdom?
Your answer should be very brief. 0.28. What is the ratio of the Balance of Payment (as % of service exports) of 2007 in Ukraine to that in United Kingdom?
Ensure brevity in your answer.  0.34. What is the ratio of the Balance of Payment (as % of service exports) in 2008 in Ukraine to that in United Kingdom?
Give a very brief answer. 0.37. What is the ratio of the Balance of Payment (as % of service exports) of 2005 in Ukraine to that in United States?
Offer a terse response. 0.38. What is the ratio of the Balance of Payment (as % of service exports) of 2006 in Ukraine to that in United States?
Your answer should be very brief. 0.43. What is the ratio of the Balance of Payment (as % of service exports) in 2007 in Ukraine to that in United States?
Your answer should be very brief. 0.52. What is the ratio of the Balance of Payment (as % of service exports) in 2008 in Ukraine to that in United States?
Give a very brief answer. 0.56. What is the ratio of the Balance of Payment (as % of service exports) of 2005 in United Kingdom to that in United States?
Your answer should be compact. 1.54. What is the ratio of the Balance of Payment (as % of service exports) of 2006 in United Kingdom to that in United States?
Ensure brevity in your answer.  1.53. What is the ratio of the Balance of Payment (as % of service exports) of 2007 in United Kingdom to that in United States?
Provide a short and direct response. 1.51. What is the ratio of the Balance of Payment (as % of service exports) in 2008 in United Kingdom to that in United States?
Your answer should be very brief. 1.5. What is the difference between the highest and the second highest Balance of Payment (as % of service exports) in 2005?
Give a very brief answer. 4.68. What is the difference between the highest and the second highest Balance of Payment (as % of service exports) in 2006?
Your response must be concise. 10.91. What is the difference between the highest and the second highest Balance of Payment (as % of service exports) of 2007?
Your response must be concise. 10.67. What is the difference between the highest and the second highest Balance of Payment (as % of service exports) of 2008?
Keep it short and to the point. 10.96. What is the difference between the highest and the lowest Balance of Payment (as % of service exports) in 2005?
Keep it short and to the point. 28.23. What is the difference between the highest and the lowest Balance of Payment (as % of service exports) of 2006?
Provide a short and direct response. 29.43. What is the difference between the highest and the lowest Balance of Payment (as % of service exports) of 2007?
Offer a very short reply. 29.13. What is the difference between the highest and the lowest Balance of Payment (as % of service exports) of 2008?
Make the answer very short. 30.09. 